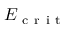Convert formula to latex. <formula><loc_0><loc_0><loc_500><loc_500>E _ { c r i t }</formula> 